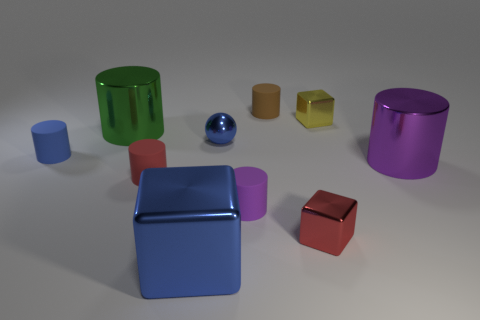There is a purple object to the left of the tiny metallic thing on the right side of the red thing to the right of the blue shiny cube; what is it made of?
Offer a very short reply. Rubber. What number of objects are big green things or small objects?
Offer a terse response. 8. The tiny purple matte thing is what shape?
Make the answer very short. Cylinder. The tiny brown matte object behind the large metallic thing that is right of the tiny metallic sphere is what shape?
Provide a succinct answer. Cylinder. Does the small object that is to the left of the large green metallic cylinder have the same material as the red block?
Your answer should be compact. No. What number of green objects are large metal balls or big cylinders?
Ensure brevity in your answer.  1. Are there any rubber things that have the same color as the metal sphere?
Make the answer very short. Yes. Is there a large block that has the same material as the green thing?
Offer a very short reply. Yes. What shape is the big object that is behind the red metallic object and on the right side of the large green metal cylinder?
Give a very brief answer. Cylinder. How many small objects are purple matte cylinders or blue metal cubes?
Your response must be concise. 1. 